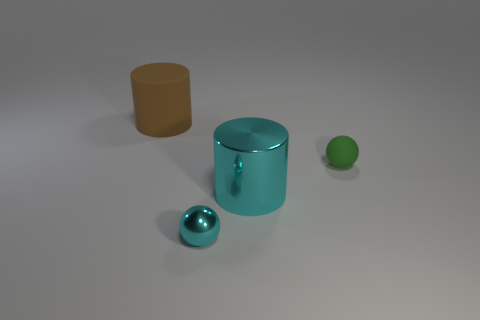What number of rubber objects have the same color as the big shiny object?
Make the answer very short. 0. How many big things are either green spheres or green cubes?
Provide a short and direct response. 0. Is the big cylinder that is in front of the tiny rubber sphere made of the same material as the large brown cylinder?
Your answer should be very brief. No. The metal thing that is behind the small cyan sphere is what color?
Keep it short and to the point. Cyan. Is there a green rubber block that has the same size as the rubber ball?
Offer a very short reply. No. What material is the ball that is the same size as the green rubber thing?
Give a very brief answer. Metal. There is a green sphere; does it have the same size as the cylinder right of the big brown matte cylinder?
Provide a short and direct response. No. There is a large object that is on the right side of the big matte thing; what is its material?
Your answer should be compact. Metal. Are there an equal number of tiny green matte objects that are on the left side of the big cyan shiny thing and cyan shiny things?
Keep it short and to the point. No. Is the size of the metallic sphere the same as the brown matte thing?
Your answer should be compact. No. 